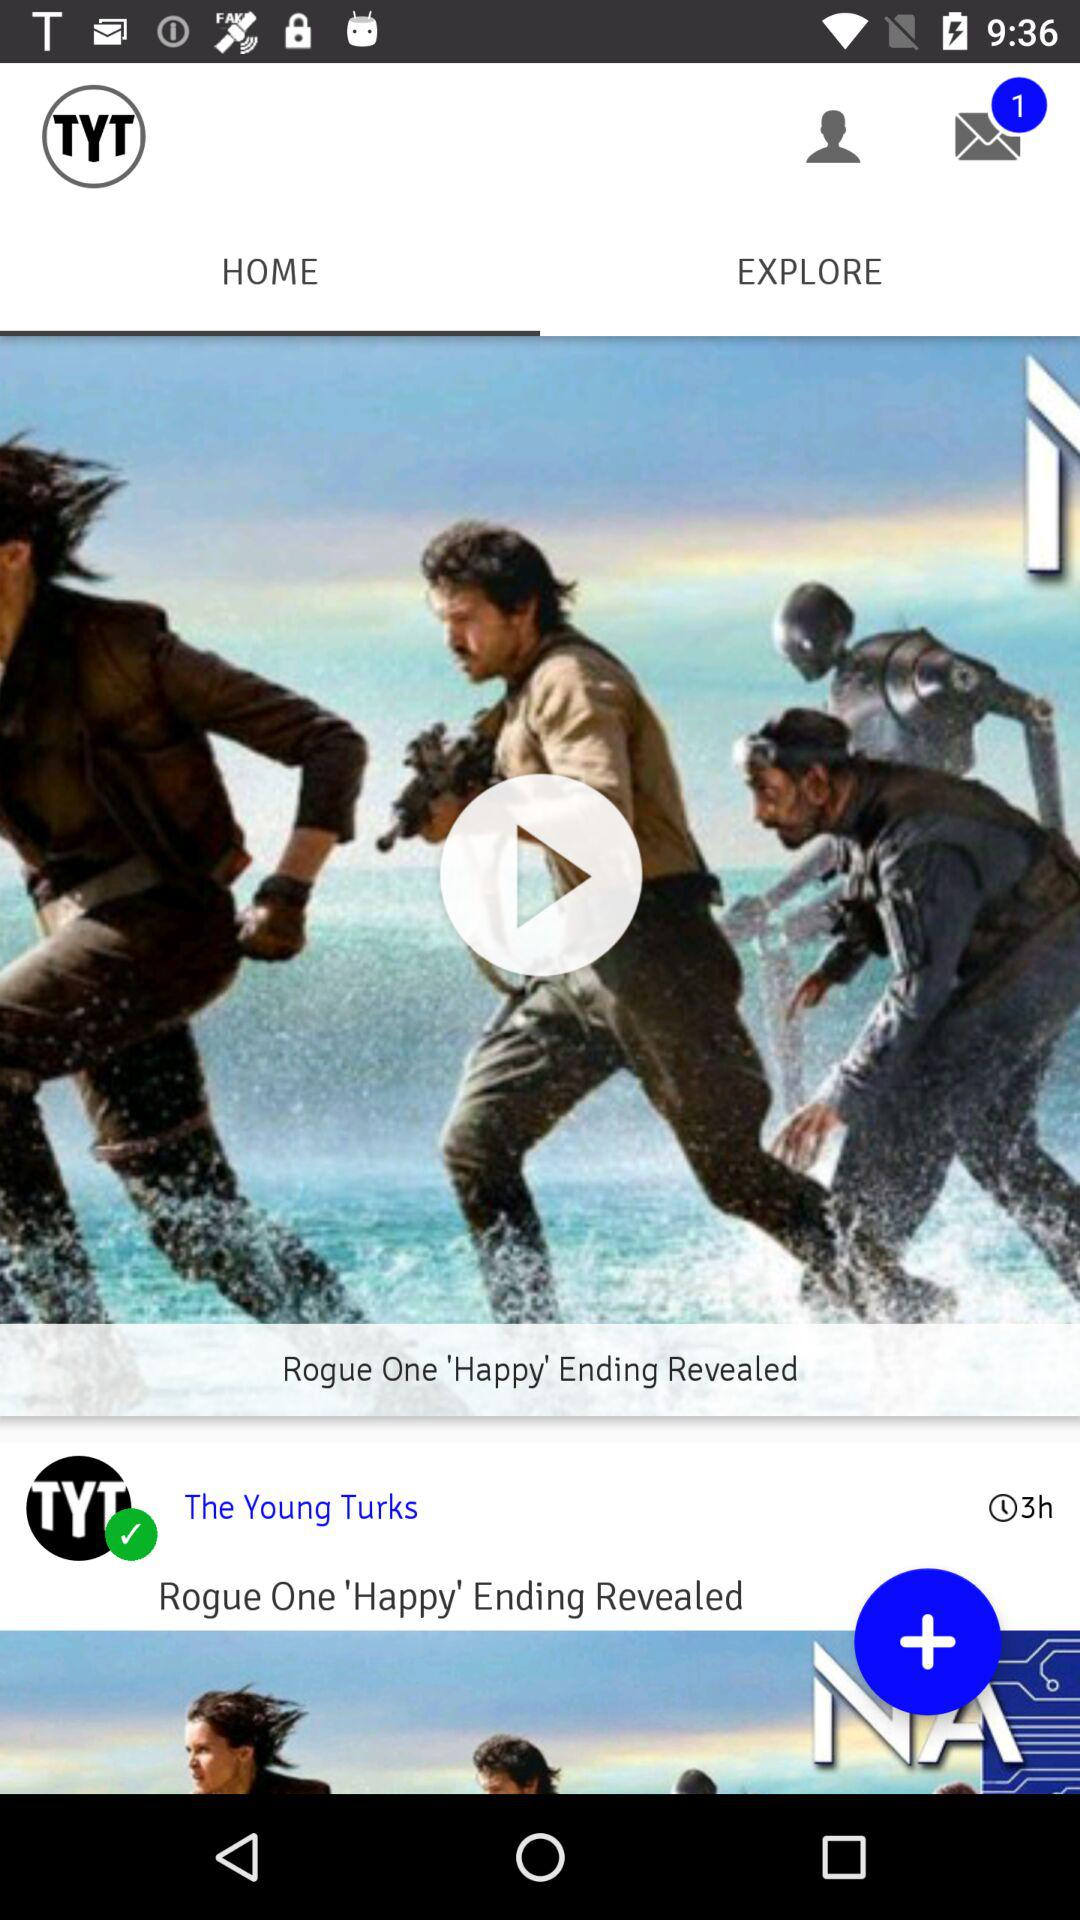Which tab is selected? The selected tab is "HOME". 